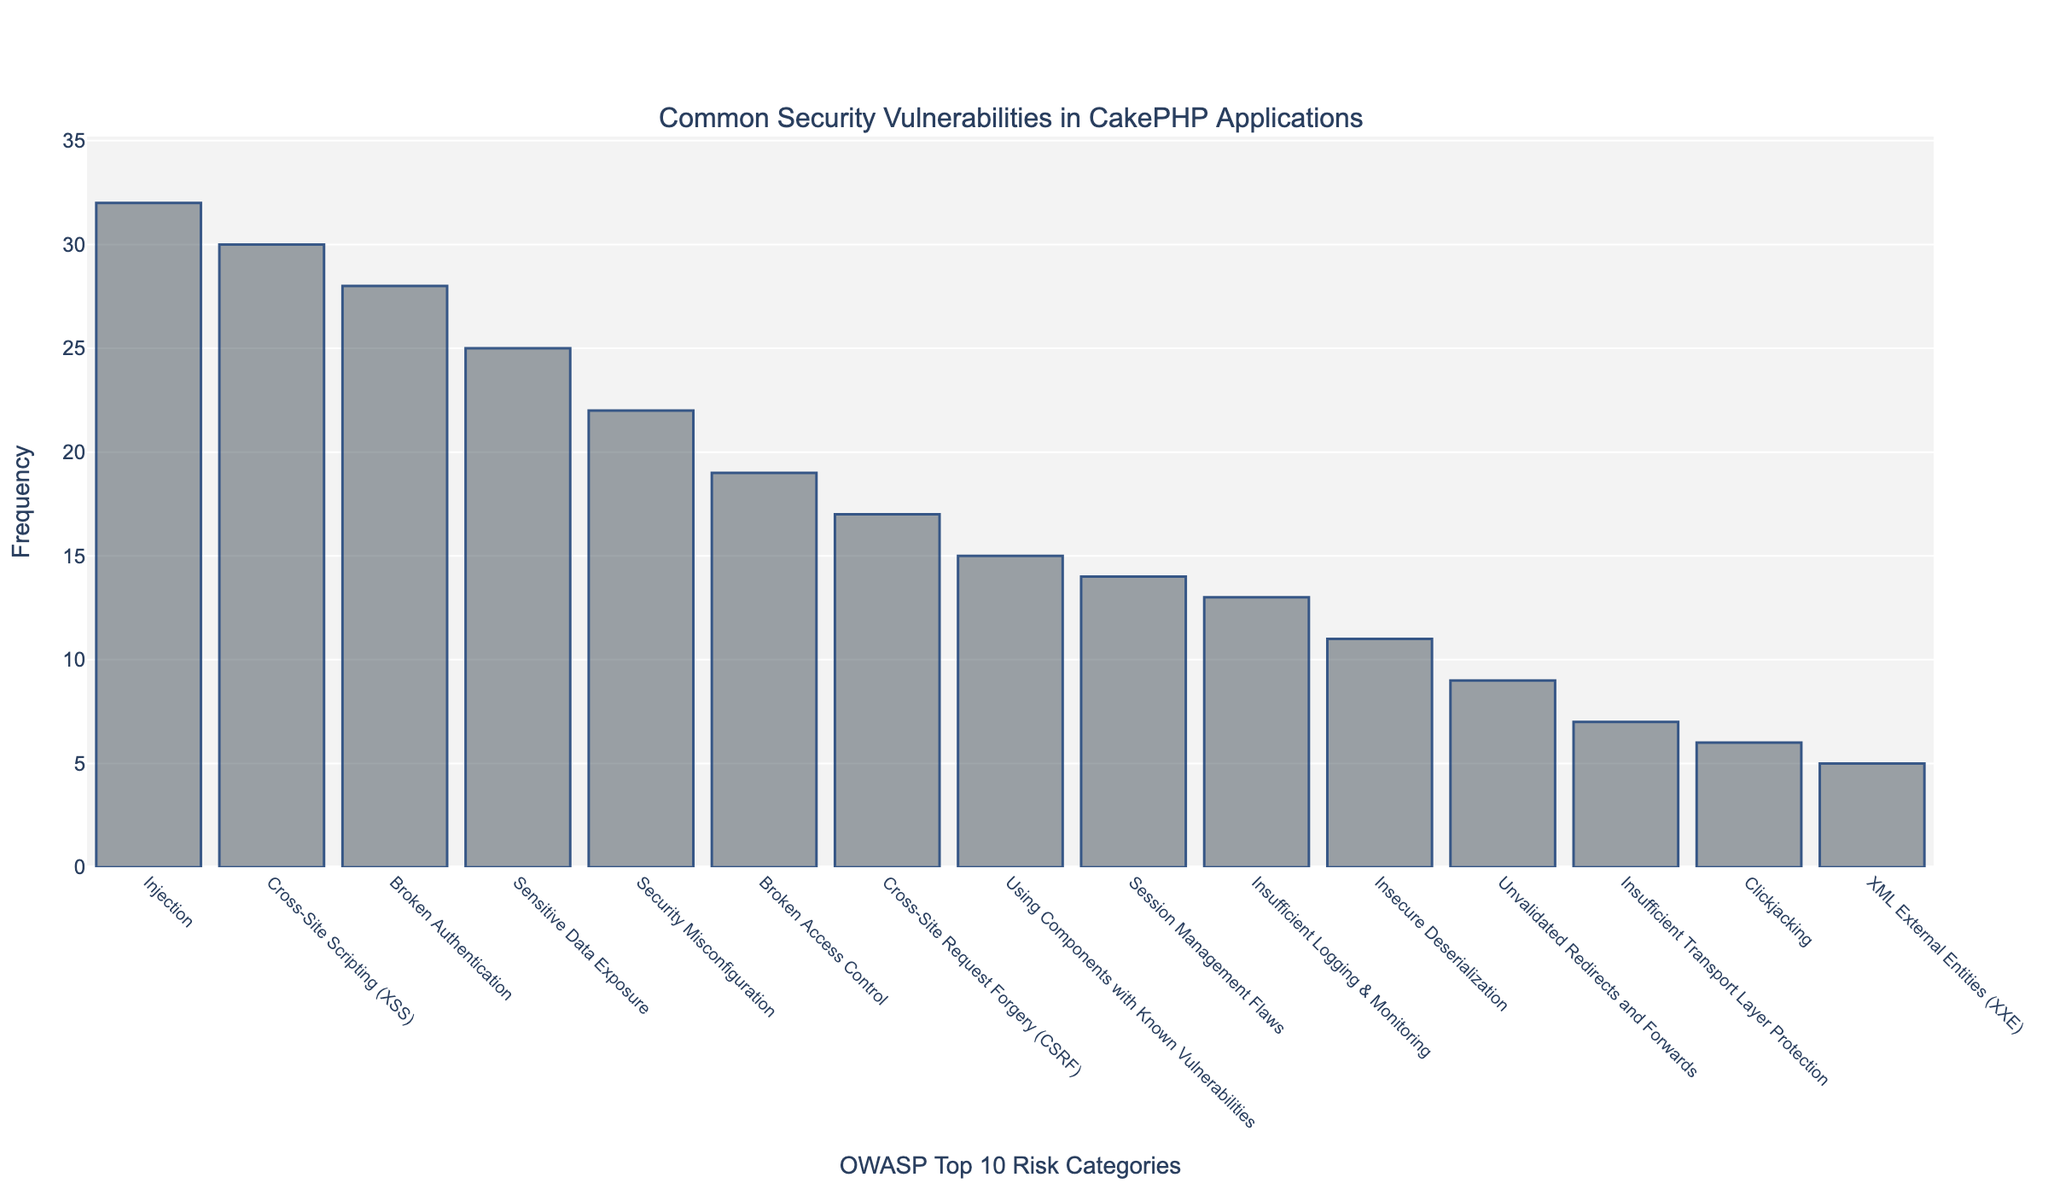Which OWASP category has the highest frequency? By looking at the bar chart, we identify the category with the tallest bar, which represents the highest frequency. The "Injection" category has the tallest bar with a frequency of 32.
Answer: Injection Which category has a higher frequency: Cross-Site Scripting (XSS) or Broken Authentication? To compare their frequencies, we locate the bars for "Cross-Site Scripting (XSS)" and "Broken Authentication". The height of the XSS bar represents a frequency of 30, and the height of the Broken Authentication bar represents a frequency of 28. Since 30 is greater than 28, XSS has a higher frequency.
Answer: Cross-Site Scripting (XSS) What is the total frequency of the three least common security vulnerabilities? The three categories with the shortest bars are "XML External Entities (XXE)" with a frequency of 5, "Clickjacking" with 6, and "Insufficient Transport Layer Protection" with 7. Adding these frequencies: 5 + 6 + 7 = 18.
Answer: 18 How many more vulnerabilities are there in the "Injection" category compared to the "Security Misconfiguration" category? We compare the frequencies of "Injection" (32) and "Security Misconfiguration" (22). Subtracting to find the difference: 32 - 22 = 10.
Answer: 10 What is the average frequency of the top 5 most common vulnerabilities? The top 5 categories in terms of frequency are: "Injection" (32), "Cross-Site Scripting (XSS)" (30), "Broken Authentication" (28), "Sensitive Data Exposure" (25), and "Security Misconfiguration" (22). Sum these frequencies: 32 + 30 + 28 + 25 + 22 = 137. Dividing by 5 to find the average: 137 / 5 = 27.4.
Answer: 27.4 Which category has slightly less than twice the frequency of "Insecure Deserialization"? The frequency of "Insecure Deserialization" is 11. Doubling this value gives 22. The "Security Misconfiguration" category has a frequency of 22, which is close to double 11.
Answer: Security Misconfiguration What is the combined frequency of vulnerabilities related to "Broken Access Control" and "Insufficient Logging & Monitoring"? The frequencies for "Broken Access Control" and "Insufficient Logging & Monitoring" are 19 and 13 respectively. Adding these together: 19 + 13 = 32.
Answer: 32 Which is higher: the frequency of "Sensitive Data Exposure" or the sum of "XML External Entities (XXE)" and "Unvalidated Redirects and Forwards"? The frequency of "Sensitive Data Exposure" is 25. The sum of "XML External Entities (XXE)" (5) and "Unvalidated Redirects and Forwards" (9) is 5 + 9 = 14. Since 25 is greater than 14, "Sensitive Data Exposure" has a higher frequency.
Answer: Sensitive Data Exposure 